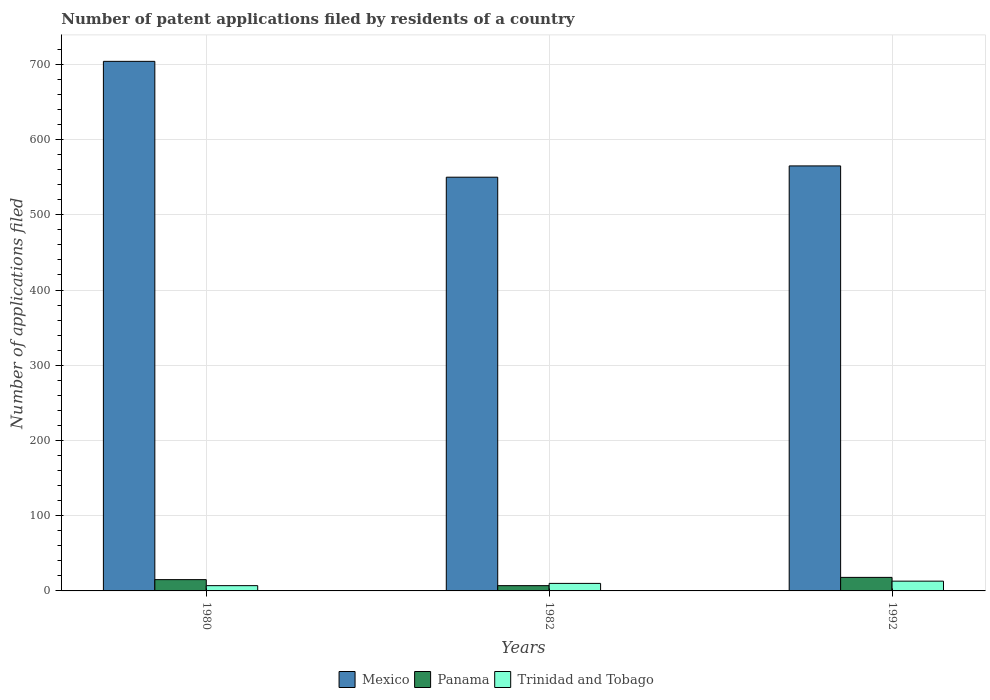Are the number of bars per tick equal to the number of legend labels?
Keep it short and to the point. Yes. What is the label of the 1st group of bars from the left?
Your answer should be compact. 1980. In how many cases, is the number of bars for a given year not equal to the number of legend labels?
Your answer should be very brief. 0. What is the number of applications filed in Panama in 1982?
Keep it short and to the point. 7. Across all years, what is the maximum number of applications filed in Mexico?
Make the answer very short. 704. Across all years, what is the minimum number of applications filed in Mexico?
Make the answer very short. 550. In which year was the number of applications filed in Panama maximum?
Make the answer very short. 1992. What is the total number of applications filed in Trinidad and Tobago in the graph?
Your answer should be very brief. 30. What is the difference between the number of applications filed in Mexico in 1982 and the number of applications filed in Panama in 1980?
Keep it short and to the point. 535. What is the average number of applications filed in Panama per year?
Offer a very short reply. 13.33. In the year 1980, what is the difference between the number of applications filed in Panama and number of applications filed in Mexico?
Provide a succinct answer. -689. In how many years, is the number of applications filed in Mexico greater than 140?
Your answer should be very brief. 3. What is the ratio of the number of applications filed in Panama in 1982 to that in 1992?
Give a very brief answer. 0.39. What is the difference between the highest and the second highest number of applications filed in Mexico?
Keep it short and to the point. 139. What is the difference between the highest and the lowest number of applications filed in Mexico?
Ensure brevity in your answer.  154. Is the sum of the number of applications filed in Mexico in 1982 and 1992 greater than the maximum number of applications filed in Panama across all years?
Give a very brief answer. Yes. What does the 3rd bar from the left in 1980 represents?
Keep it short and to the point. Trinidad and Tobago. What does the 2nd bar from the right in 1980 represents?
Your response must be concise. Panama. Are all the bars in the graph horizontal?
Make the answer very short. No. What is the difference between two consecutive major ticks on the Y-axis?
Make the answer very short. 100. Are the values on the major ticks of Y-axis written in scientific E-notation?
Your answer should be compact. No. Does the graph contain any zero values?
Provide a short and direct response. No. Does the graph contain grids?
Give a very brief answer. Yes. Where does the legend appear in the graph?
Provide a succinct answer. Bottom center. How are the legend labels stacked?
Provide a short and direct response. Horizontal. What is the title of the graph?
Offer a terse response. Number of patent applications filed by residents of a country. Does "Italy" appear as one of the legend labels in the graph?
Provide a short and direct response. No. What is the label or title of the Y-axis?
Offer a terse response. Number of applications filed. What is the Number of applications filed in Mexico in 1980?
Offer a very short reply. 704. What is the Number of applications filed in Panama in 1980?
Provide a short and direct response. 15. What is the Number of applications filed in Mexico in 1982?
Provide a succinct answer. 550. What is the Number of applications filed of Panama in 1982?
Your answer should be compact. 7. What is the Number of applications filed in Trinidad and Tobago in 1982?
Provide a short and direct response. 10. What is the Number of applications filed in Mexico in 1992?
Make the answer very short. 565. What is the Number of applications filed in Panama in 1992?
Your response must be concise. 18. What is the Number of applications filed of Trinidad and Tobago in 1992?
Your answer should be very brief. 13. Across all years, what is the maximum Number of applications filed of Mexico?
Offer a very short reply. 704. Across all years, what is the maximum Number of applications filed of Panama?
Provide a short and direct response. 18. Across all years, what is the maximum Number of applications filed in Trinidad and Tobago?
Offer a terse response. 13. Across all years, what is the minimum Number of applications filed of Mexico?
Keep it short and to the point. 550. Across all years, what is the minimum Number of applications filed of Panama?
Give a very brief answer. 7. What is the total Number of applications filed in Mexico in the graph?
Provide a succinct answer. 1819. What is the total Number of applications filed in Panama in the graph?
Provide a short and direct response. 40. What is the difference between the Number of applications filed of Mexico in 1980 and that in 1982?
Offer a terse response. 154. What is the difference between the Number of applications filed of Trinidad and Tobago in 1980 and that in 1982?
Offer a terse response. -3. What is the difference between the Number of applications filed in Mexico in 1980 and that in 1992?
Ensure brevity in your answer.  139. What is the difference between the Number of applications filed of Panama in 1980 and that in 1992?
Your answer should be compact. -3. What is the difference between the Number of applications filed of Trinidad and Tobago in 1982 and that in 1992?
Your answer should be very brief. -3. What is the difference between the Number of applications filed of Mexico in 1980 and the Number of applications filed of Panama in 1982?
Provide a succinct answer. 697. What is the difference between the Number of applications filed in Mexico in 1980 and the Number of applications filed in Trinidad and Tobago in 1982?
Provide a succinct answer. 694. What is the difference between the Number of applications filed of Panama in 1980 and the Number of applications filed of Trinidad and Tobago in 1982?
Give a very brief answer. 5. What is the difference between the Number of applications filed in Mexico in 1980 and the Number of applications filed in Panama in 1992?
Provide a succinct answer. 686. What is the difference between the Number of applications filed in Mexico in 1980 and the Number of applications filed in Trinidad and Tobago in 1992?
Provide a short and direct response. 691. What is the difference between the Number of applications filed in Mexico in 1982 and the Number of applications filed in Panama in 1992?
Your response must be concise. 532. What is the difference between the Number of applications filed in Mexico in 1982 and the Number of applications filed in Trinidad and Tobago in 1992?
Provide a short and direct response. 537. What is the difference between the Number of applications filed of Panama in 1982 and the Number of applications filed of Trinidad and Tobago in 1992?
Provide a short and direct response. -6. What is the average Number of applications filed of Mexico per year?
Your response must be concise. 606.33. What is the average Number of applications filed of Panama per year?
Offer a very short reply. 13.33. What is the average Number of applications filed in Trinidad and Tobago per year?
Provide a succinct answer. 10. In the year 1980, what is the difference between the Number of applications filed in Mexico and Number of applications filed in Panama?
Make the answer very short. 689. In the year 1980, what is the difference between the Number of applications filed in Mexico and Number of applications filed in Trinidad and Tobago?
Your answer should be compact. 697. In the year 1980, what is the difference between the Number of applications filed in Panama and Number of applications filed in Trinidad and Tobago?
Your answer should be compact. 8. In the year 1982, what is the difference between the Number of applications filed in Mexico and Number of applications filed in Panama?
Your response must be concise. 543. In the year 1982, what is the difference between the Number of applications filed of Mexico and Number of applications filed of Trinidad and Tobago?
Provide a succinct answer. 540. In the year 1982, what is the difference between the Number of applications filed in Panama and Number of applications filed in Trinidad and Tobago?
Your response must be concise. -3. In the year 1992, what is the difference between the Number of applications filed in Mexico and Number of applications filed in Panama?
Your response must be concise. 547. In the year 1992, what is the difference between the Number of applications filed of Mexico and Number of applications filed of Trinidad and Tobago?
Your response must be concise. 552. What is the ratio of the Number of applications filed of Mexico in 1980 to that in 1982?
Your response must be concise. 1.28. What is the ratio of the Number of applications filed of Panama in 1980 to that in 1982?
Keep it short and to the point. 2.14. What is the ratio of the Number of applications filed in Mexico in 1980 to that in 1992?
Provide a succinct answer. 1.25. What is the ratio of the Number of applications filed in Trinidad and Tobago in 1980 to that in 1992?
Ensure brevity in your answer.  0.54. What is the ratio of the Number of applications filed of Mexico in 1982 to that in 1992?
Provide a succinct answer. 0.97. What is the ratio of the Number of applications filed in Panama in 1982 to that in 1992?
Offer a terse response. 0.39. What is the ratio of the Number of applications filed in Trinidad and Tobago in 1982 to that in 1992?
Ensure brevity in your answer.  0.77. What is the difference between the highest and the second highest Number of applications filed of Mexico?
Provide a succinct answer. 139. What is the difference between the highest and the second highest Number of applications filed of Trinidad and Tobago?
Offer a very short reply. 3. What is the difference between the highest and the lowest Number of applications filed in Mexico?
Keep it short and to the point. 154. What is the difference between the highest and the lowest Number of applications filed in Trinidad and Tobago?
Your response must be concise. 6. 